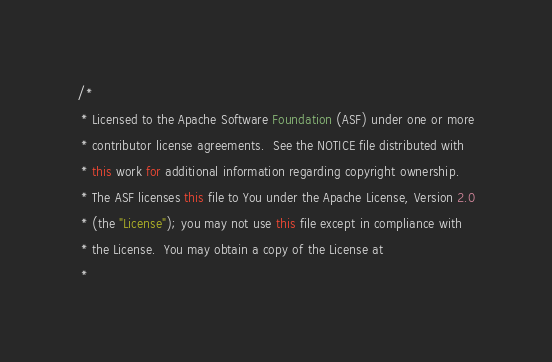<code> <loc_0><loc_0><loc_500><loc_500><_Java_>/*
 * Licensed to the Apache Software Foundation (ASF) under one or more
 * contributor license agreements.  See the NOTICE file distributed with
 * this work for additional information regarding copyright ownership.
 * The ASF licenses this file to You under the Apache License, Version 2.0
 * (the "License"); you may not use this file except in compliance with
 * the License.  You may obtain a copy of the License at
 *</code> 